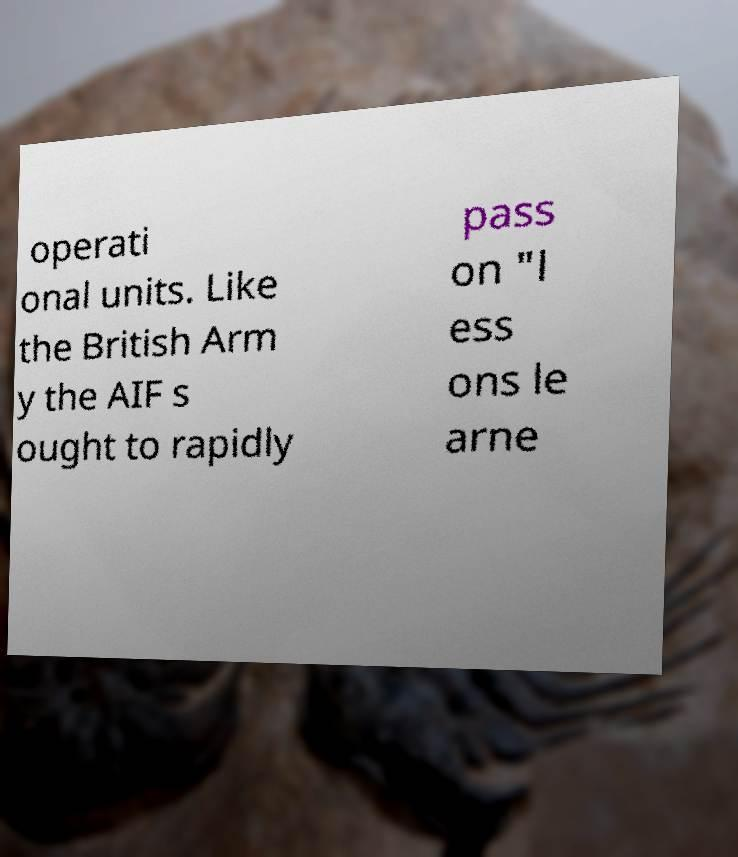For documentation purposes, I need the text within this image transcribed. Could you provide that? operati onal units. Like the British Arm y the AIF s ought to rapidly pass on "l ess ons le arne 